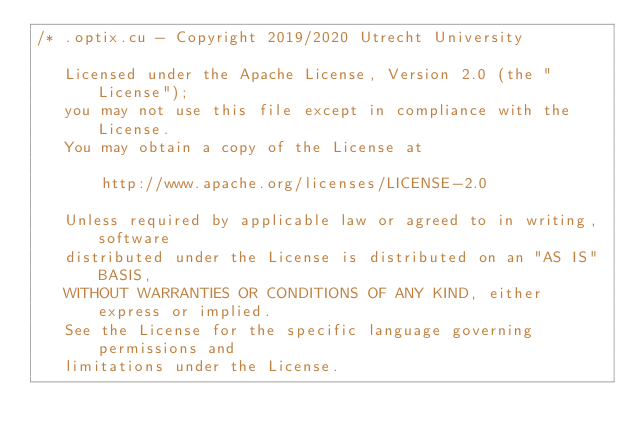Convert code to text. <code><loc_0><loc_0><loc_500><loc_500><_Cuda_>/* .optix.cu - Copyright 2019/2020 Utrecht University

   Licensed under the Apache License, Version 2.0 (the "License");
   you may not use this file except in compliance with the License.
   You may obtain a copy of the License at

	   http://www.apache.org/licenses/LICENSE-2.0

   Unless required by applicable law or agreed to in writing, software
   distributed under the License is distributed on an "AS IS" BASIS,
   WITHOUT WARRANTIES OR CONDITIONS OF ANY KIND, either express or implied.
   See the License for the specific language governing permissions and
   limitations under the License.
</code> 